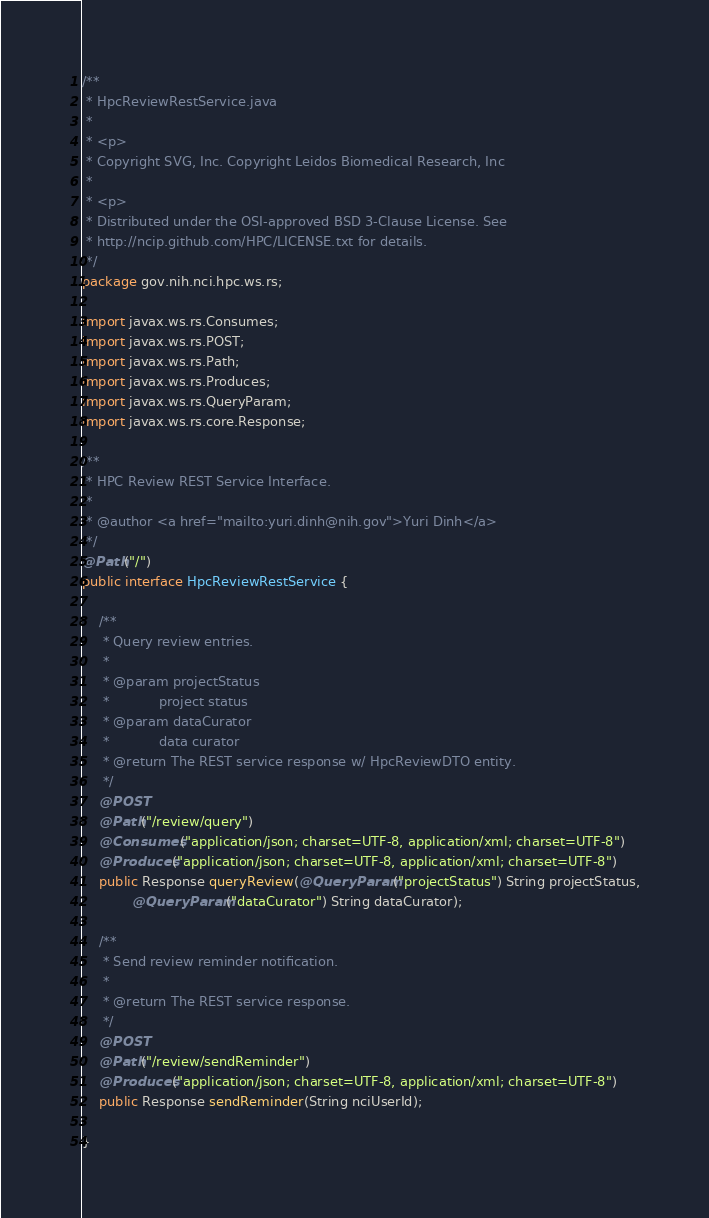<code> <loc_0><loc_0><loc_500><loc_500><_Java_>/**
 * HpcReviewRestService.java
 *
 * <p>
 * Copyright SVG, Inc. Copyright Leidos Biomedical Research, Inc
 *
 * <p>
 * Distributed under the OSI-approved BSD 3-Clause License. See
 * http://ncip.github.com/HPC/LICENSE.txt for details.
 */
package gov.nih.nci.hpc.ws.rs;

import javax.ws.rs.Consumes;
import javax.ws.rs.POST;
import javax.ws.rs.Path;
import javax.ws.rs.Produces;
import javax.ws.rs.QueryParam;
import javax.ws.rs.core.Response;

/**
 * HPC Review REST Service Interface.
 *
 * @author <a href="mailto:yuri.dinh@nih.gov">Yuri Dinh</a>
 */
@Path("/")
public interface HpcReviewRestService {

	/**
	 * Query review entries.
	 *
	 * @param projectStatus
	 *            project status
	 * @param dataCurator
	 *            data curator
	 * @return The REST service response w/ HpcReviewDTO entity.
	 */
	@POST
	@Path("/review/query")
	@Consumes("application/json; charset=UTF-8, application/xml; charset=UTF-8")
	@Produces("application/json; charset=UTF-8, application/xml; charset=UTF-8")
	public Response queryReview(@QueryParam("projectStatus") String projectStatus,
			@QueryParam("dataCurator") String dataCurator);

	/**
	 * Send review reminder notification.
	 *
	 * @return The REST service response.
	 */
	@POST
	@Path("/review/sendReminder")
	@Produces("application/json; charset=UTF-8, application/xml; charset=UTF-8")
	public Response sendReminder(String nciUserId);

}
</code> 